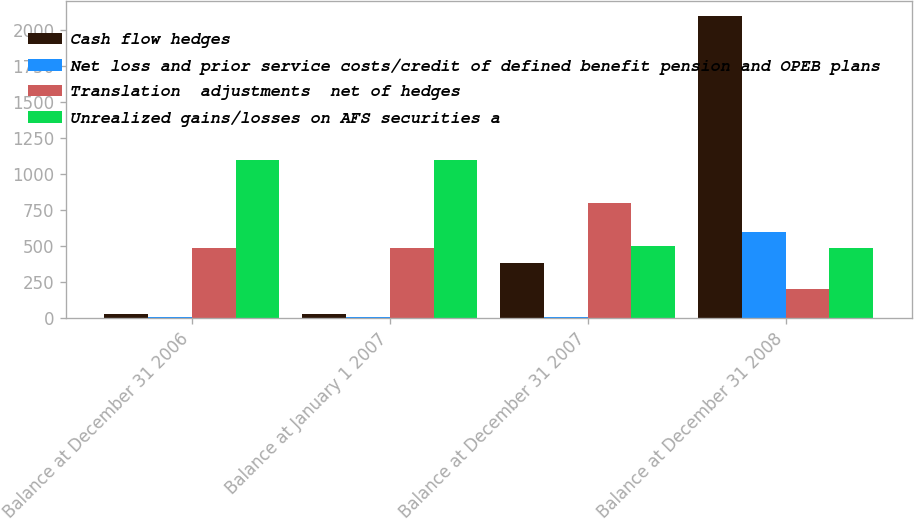<chart> <loc_0><loc_0><loc_500><loc_500><stacked_bar_chart><ecel><fcel>Balance at December 31 2006<fcel>Balance at January 1 2007<fcel>Balance at December 31 2007<fcel>Balance at December 31 2008<nl><fcel>Cash flow hedges<fcel>29<fcel>28<fcel>380<fcel>2101<nl><fcel>Net loss and prior service costs/credit of defined benefit pension and OPEB plans<fcel>5<fcel>5<fcel>8<fcel>598<nl><fcel>Translation  adjustments  net of hedges<fcel>489<fcel>489<fcel>802<fcel>202<nl><fcel>Unrealized gains/losses on AFS securities a<fcel>1102<fcel>1102<fcel>503<fcel>489<nl></chart> 